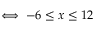Convert formula to latex. <formula><loc_0><loc_0><loc_500><loc_500>\iff - 6 \leq x \leq 1 2</formula> 